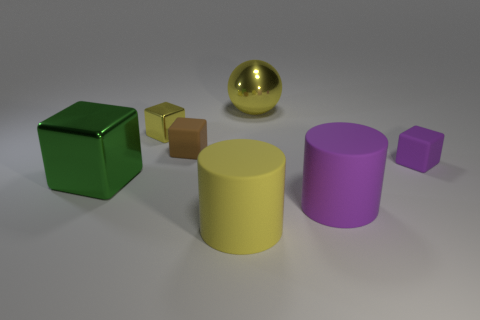Are there any other things that are the same size as the green block?
Your answer should be compact. Yes. Is the metallic sphere the same color as the tiny metallic object?
Offer a very short reply. Yes. What is the material of the yellow ball that is the same size as the yellow matte thing?
Your answer should be compact. Metal. There is a metal thing that is the same size as the green cube; what color is it?
Give a very brief answer. Yellow. The large metallic thing that is in front of the large thing that is behind the small brown rubber block is what shape?
Provide a succinct answer. Cube. There is a shiny object behind the small metallic block; is its color the same as the tiny shiny block?
Your answer should be very brief. Yes. There is a metallic object that is both to the right of the large cube and left of the big yellow sphere; what is its color?
Provide a succinct answer. Yellow. Is there a large red thing that has the same material as the small yellow object?
Give a very brief answer. No. What size is the brown matte object?
Make the answer very short. Small. What size is the yellow object in front of the small object behind the small brown block?
Ensure brevity in your answer.  Large. 